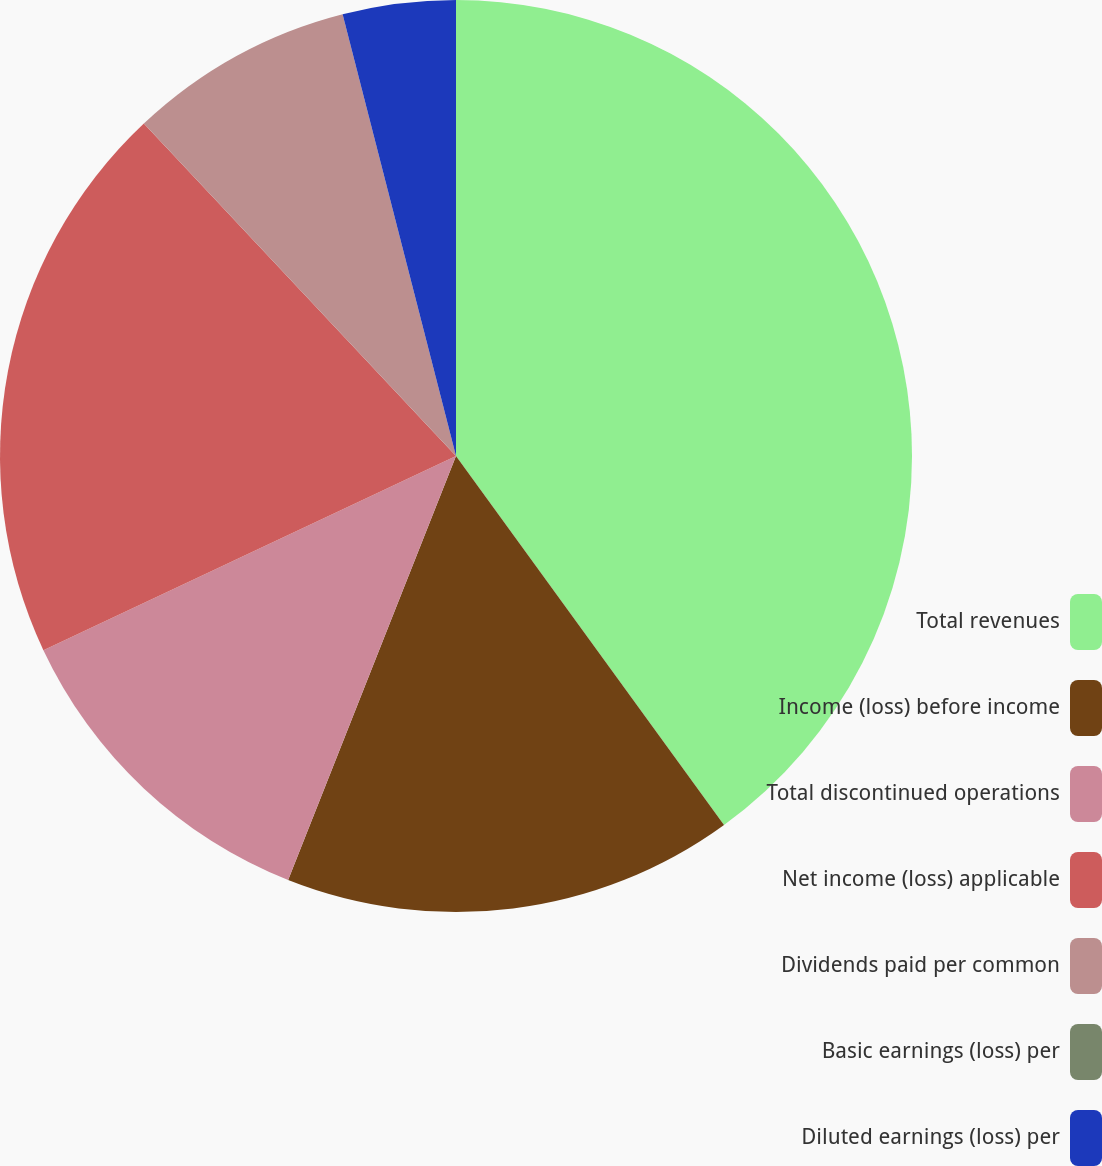<chart> <loc_0><loc_0><loc_500><loc_500><pie_chart><fcel>Total revenues<fcel>Income (loss) before income<fcel>Total discontinued operations<fcel>Net income (loss) applicable<fcel>Dividends paid per common<fcel>Basic earnings (loss) per<fcel>Diluted earnings (loss) per<nl><fcel>40.0%<fcel>16.0%<fcel>12.0%<fcel>20.0%<fcel>8.0%<fcel>0.0%<fcel>4.0%<nl></chart> 